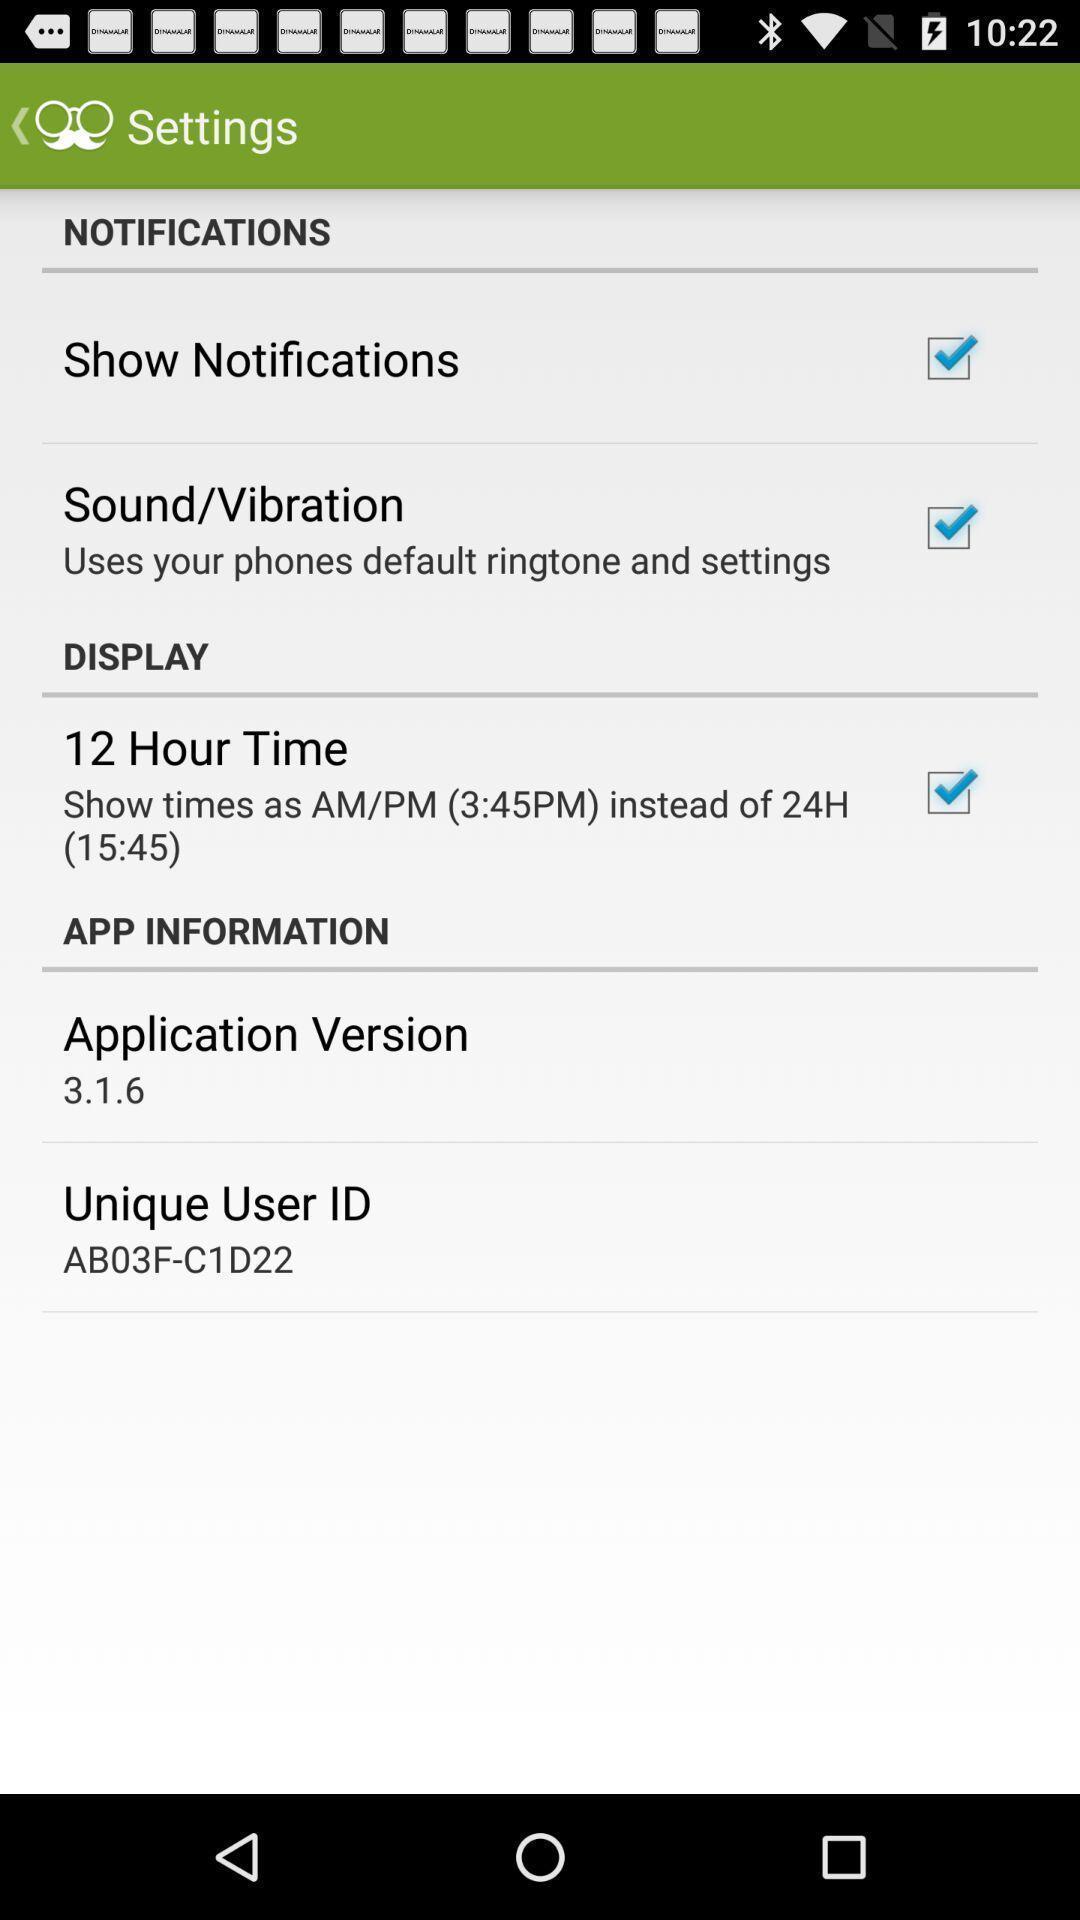Provide a textual representation of this image. Settings page displaying in application. 